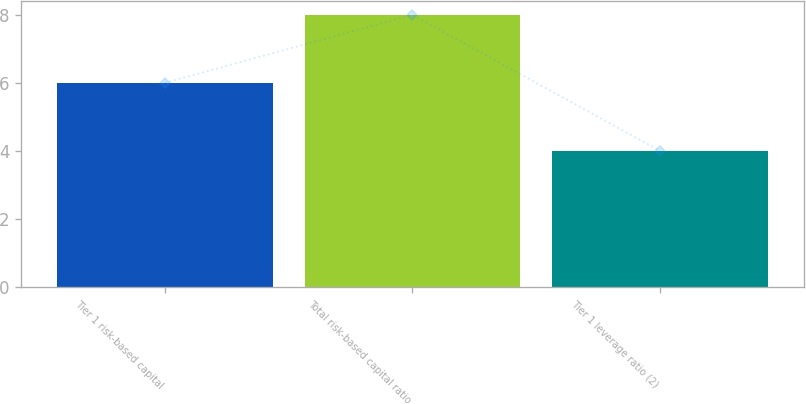Convert chart to OTSL. <chart><loc_0><loc_0><loc_500><loc_500><bar_chart><fcel>Tier 1 risk-based capital<fcel>Total risk-based capital ratio<fcel>Tier 1 leverage ratio (2)<nl><fcel>6<fcel>8<fcel>4<nl></chart> 